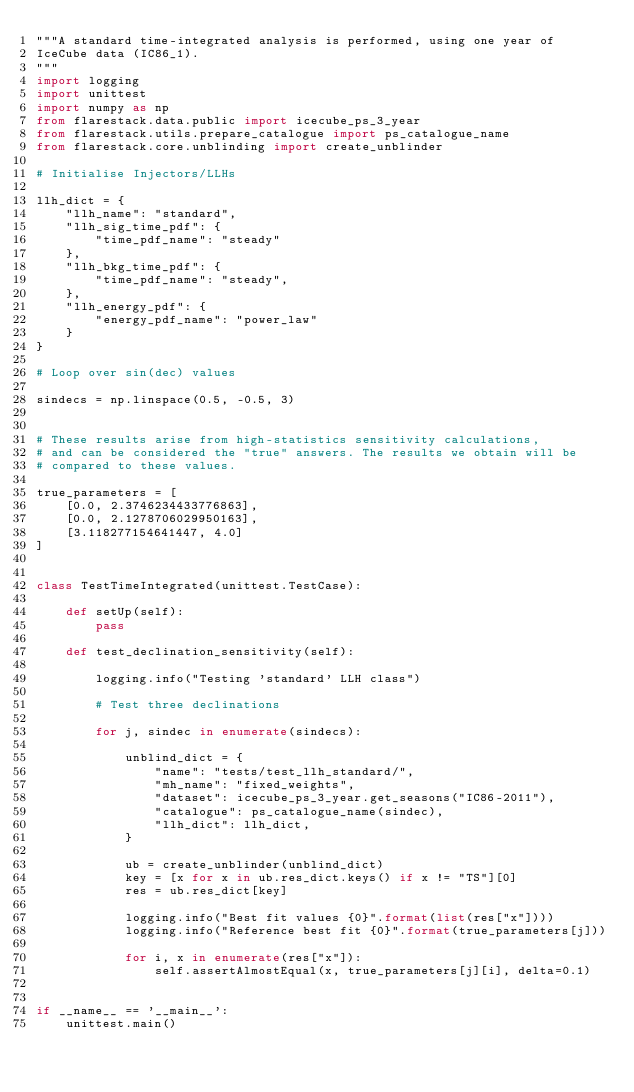<code> <loc_0><loc_0><loc_500><loc_500><_Python_>"""A standard time-integrated analysis is performed, using one year of
IceCube data (IC86_1).
"""
import logging
import unittest
import numpy as np
from flarestack.data.public import icecube_ps_3_year
from flarestack.utils.prepare_catalogue import ps_catalogue_name
from flarestack.core.unblinding import create_unblinder

# Initialise Injectors/LLHs

llh_dict = {
    "llh_name": "standard",
    "llh_sig_time_pdf": {
        "time_pdf_name": "steady"
    },
    "llh_bkg_time_pdf": {
        "time_pdf_name": "steady",
    },
    "llh_energy_pdf": {
        "energy_pdf_name": "power_law"
    }
}

# Loop over sin(dec) values

sindecs = np.linspace(0.5, -0.5, 3)


# These results arise from high-statistics sensitivity calculations,
# and can be considered the "true" answers. The results we obtain will be
# compared to these values.

true_parameters = [
    [0.0, 2.3746234433776863],
    [0.0, 2.1278706029950163],
    [3.118277154641447, 4.0]
]


class TestTimeIntegrated(unittest.TestCase):

    def setUp(self):
        pass

    def test_declination_sensitivity(self):

        logging.info("Testing 'standard' LLH class")

        # Test three declinations

        for j, sindec in enumerate(sindecs):

            unblind_dict = {
                "name": "tests/test_llh_standard/",
                "mh_name": "fixed_weights",
                "dataset": icecube_ps_3_year.get_seasons("IC86-2011"),
                "catalogue": ps_catalogue_name(sindec),
                "llh_dict": llh_dict,
            }

            ub = create_unblinder(unblind_dict)
            key = [x for x in ub.res_dict.keys() if x != "TS"][0]
            res = ub.res_dict[key]

            logging.info("Best fit values {0}".format(list(res["x"])))
            logging.info("Reference best fit {0}".format(true_parameters[j]))

            for i, x in enumerate(res["x"]):
                self.assertAlmostEqual(x, true_parameters[j][i], delta=0.1)


if __name__ == '__main__':
    unittest.main()
</code> 